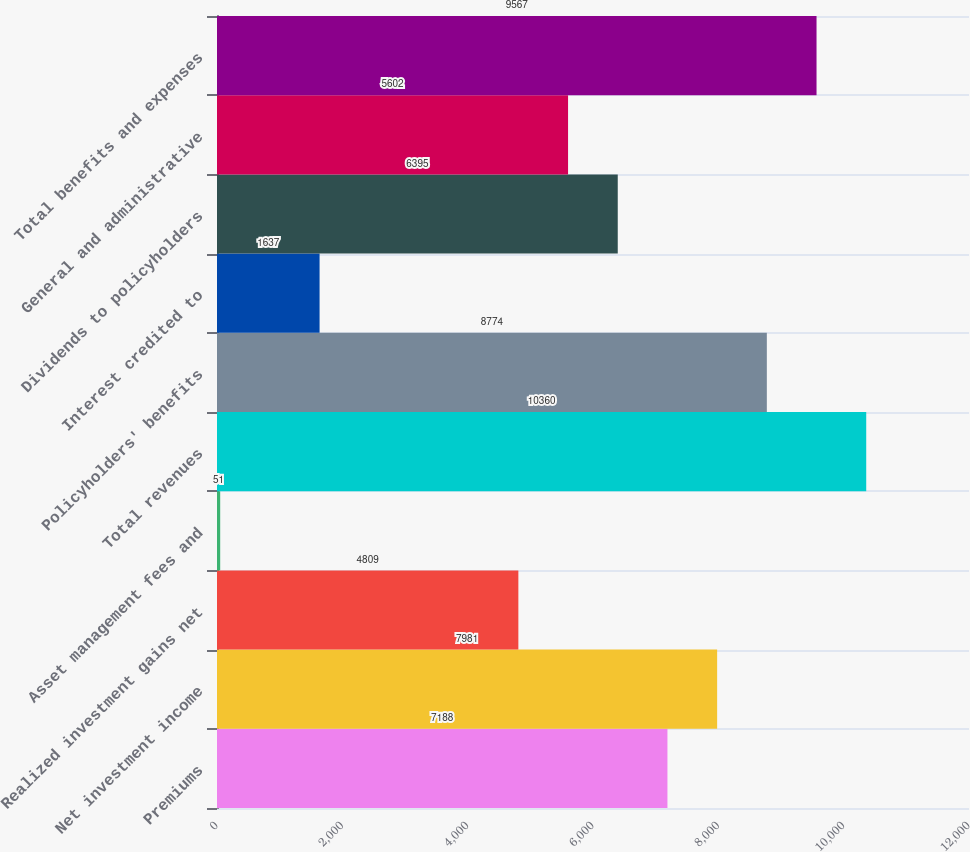<chart> <loc_0><loc_0><loc_500><loc_500><bar_chart><fcel>Premiums<fcel>Net investment income<fcel>Realized investment gains net<fcel>Asset management fees and<fcel>Total revenues<fcel>Policyholders' benefits<fcel>Interest credited to<fcel>Dividends to policyholders<fcel>General and administrative<fcel>Total benefits and expenses<nl><fcel>7188<fcel>7981<fcel>4809<fcel>51<fcel>10360<fcel>8774<fcel>1637<fcel>6395<fcel>5602<fcel>9567<nl></chart> 